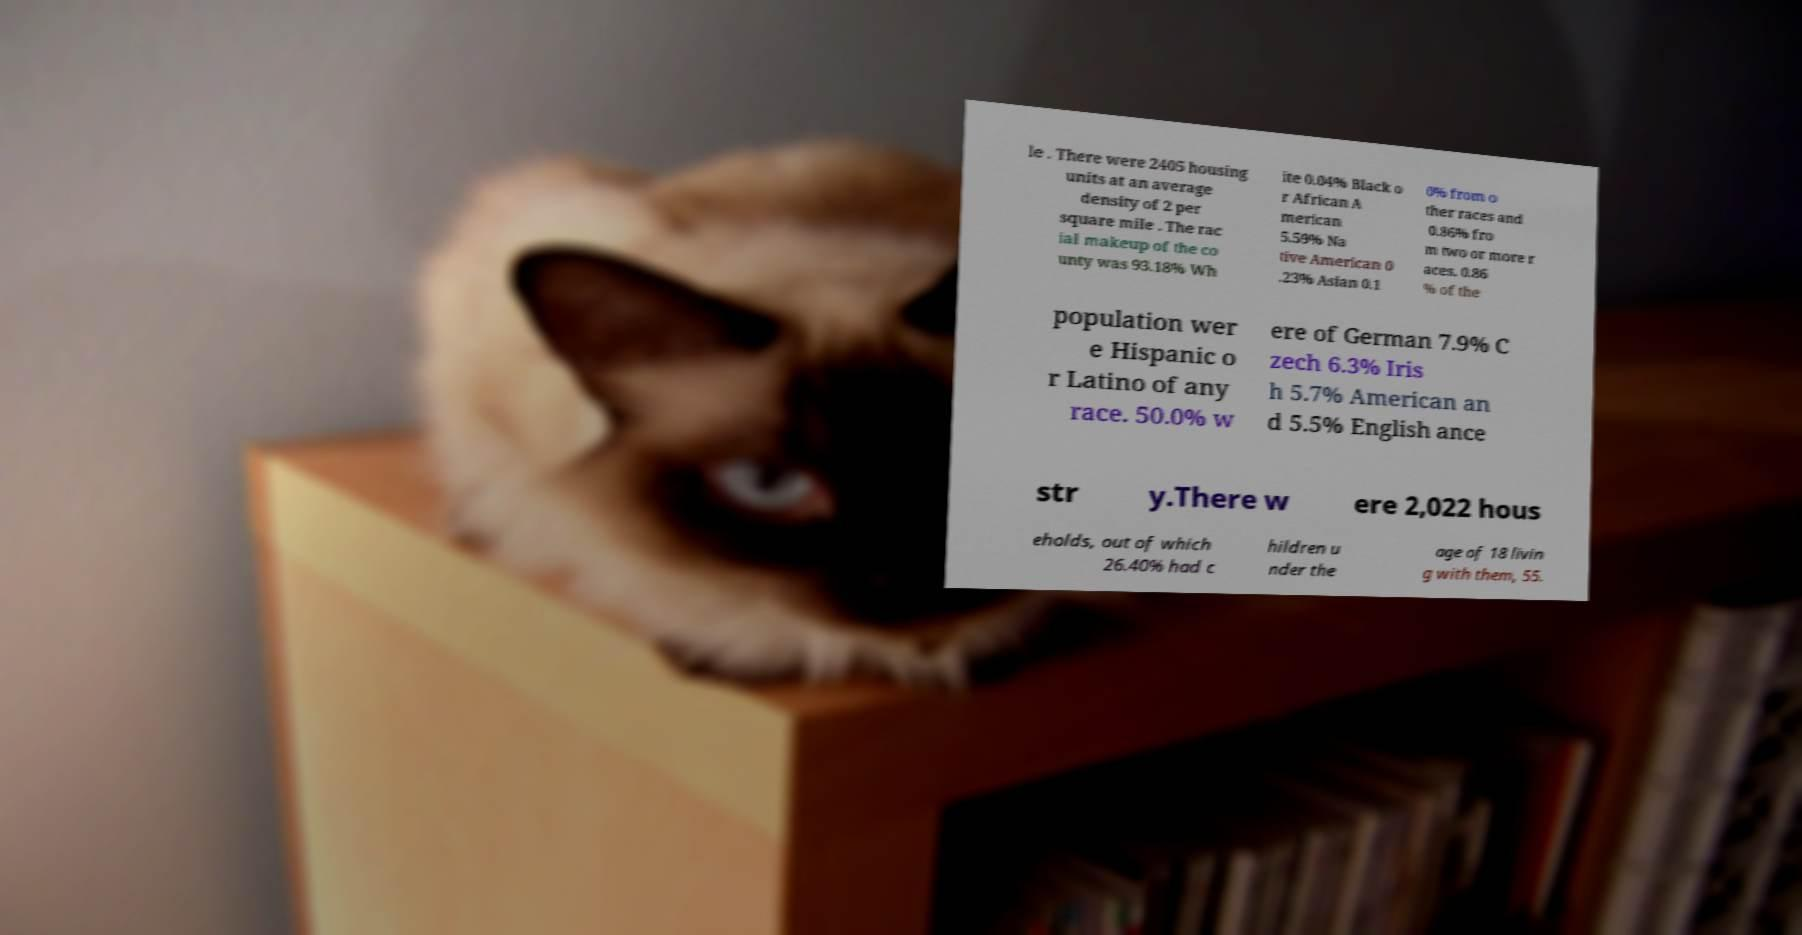For documentation purposes, I need the text within this image transcribed. Could you provide that? le . There were 2405 housing units at an average density of 2 per square mile . The rac ial makeup of the co unty was 93.18% Wh ite 0.04% Black o r African A merican 5.59% Na tive American 0 .23% Asian 0.1 0% from o ther races and 0.86% fro m two or more r aces. 0.86 % of the population wer e Hispanic o r Latino of any race. 50.0% w ere of German 7.9% C zech 6.3% Iris h 5.7% American an d 5.5% English ance str y.There w ere 2,022 hous eholds, out of which 26.40% had c hildren u nder the age of 18 livin g with them, 55. 